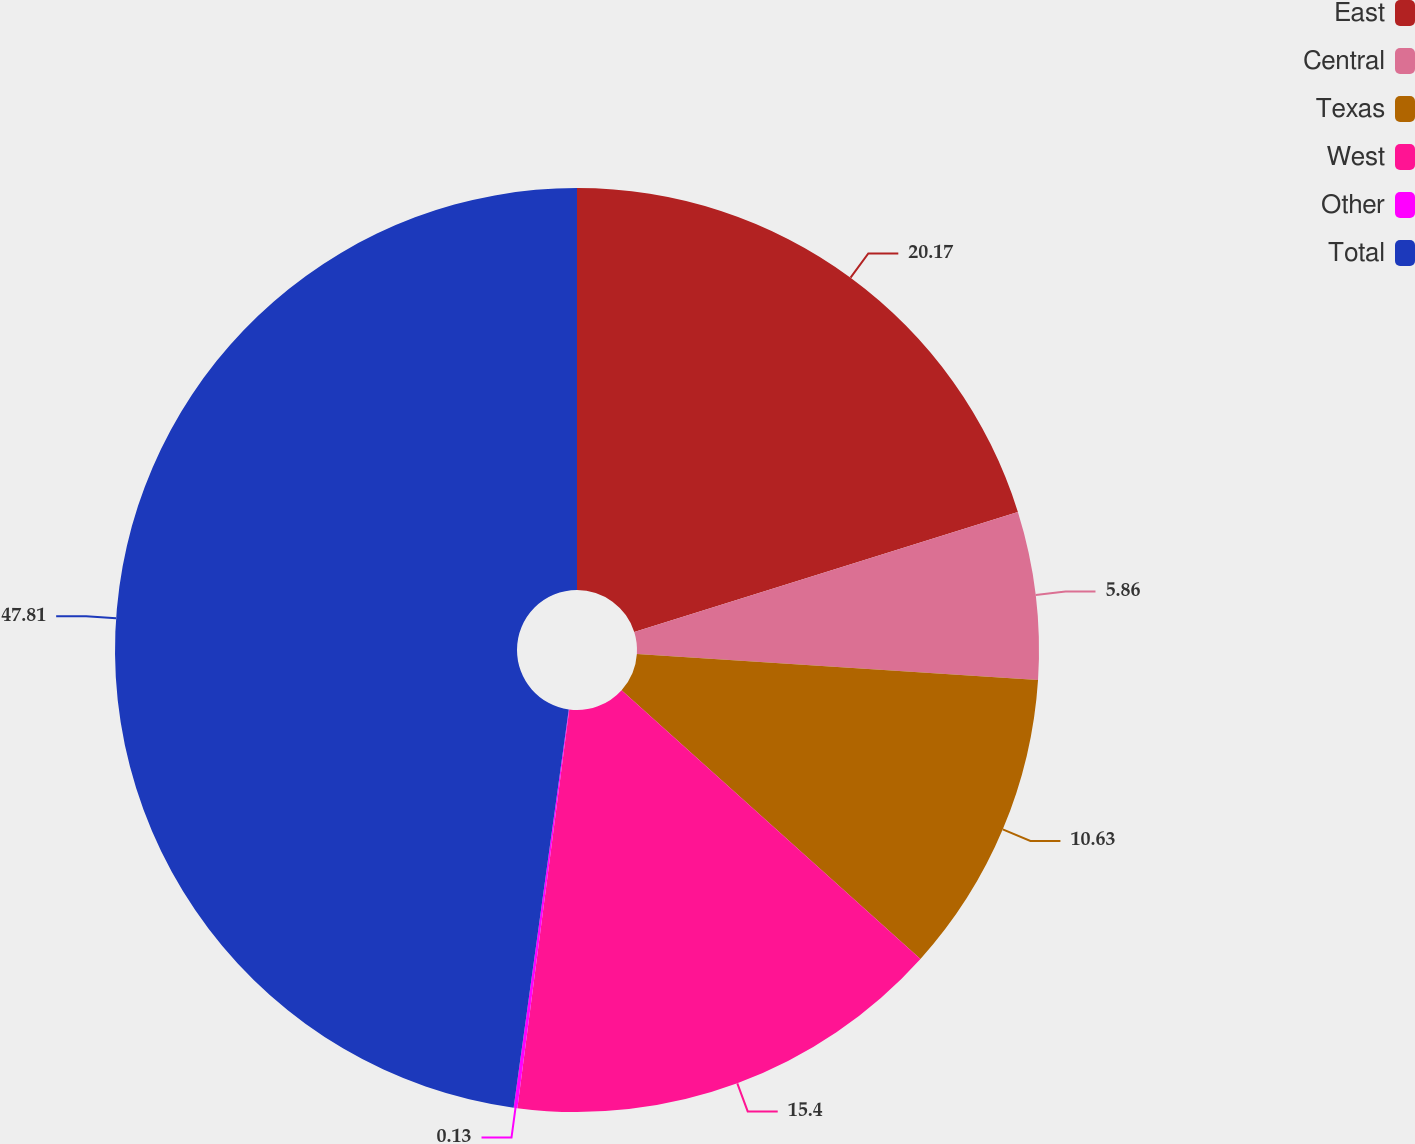Convert chart to OTSL. <chart><loc_0><loc_0><loc_500><loc_500><pie_chart><fcel>East<fcel>Central<fcel>Texas<fcel>West<fcel>Other<fcel>Total<nl><fcel>20.17%<fcel>5.86%<fcel>10.63%<fcel>15.4%<fcel>0.13%<fcel>47.81%<nl></chart> 